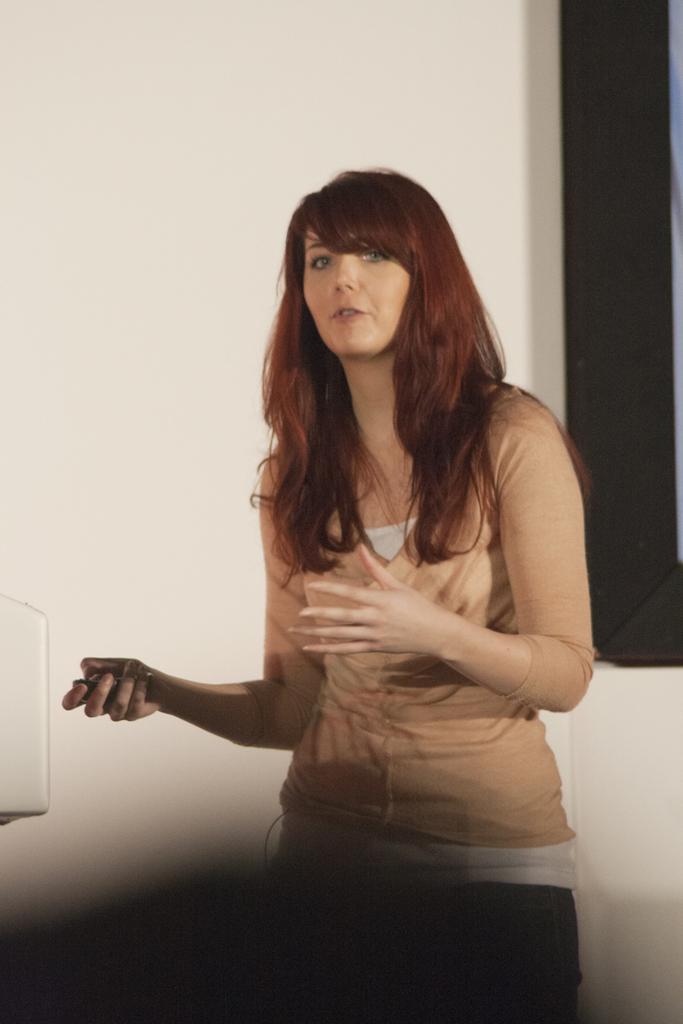Could you give a brief overview of what you see in this image? In this picture there is a woman standing and talking, behind her we can see a wall and an object. On the left side of the image we can see a white object. 